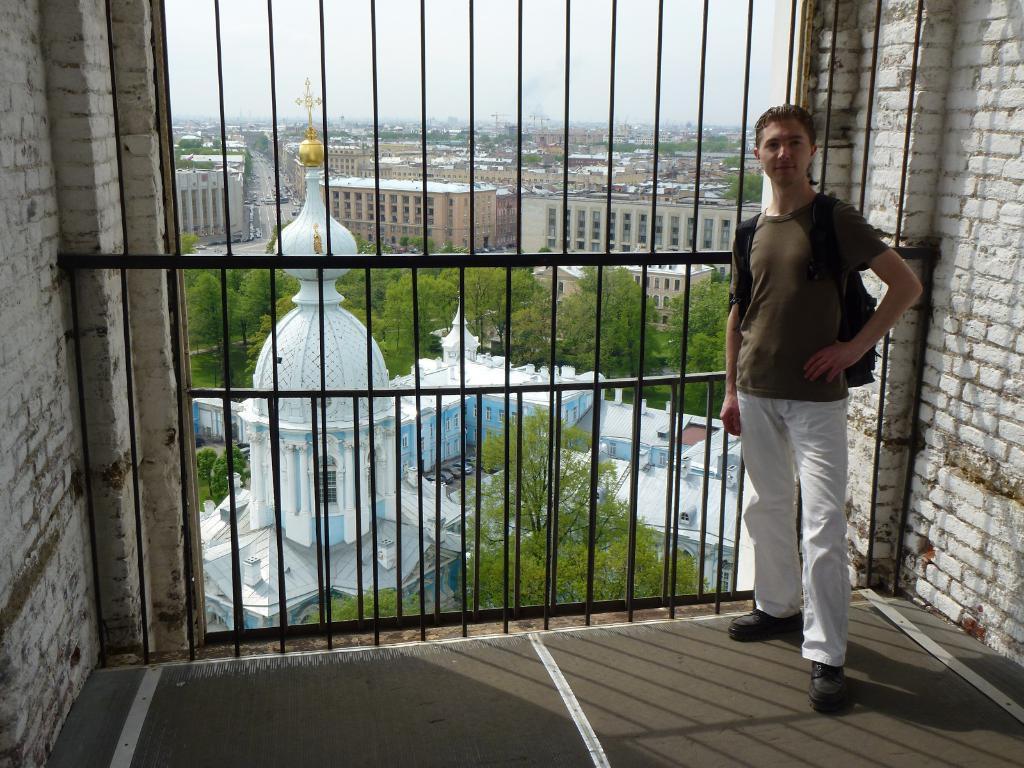In one or two sentences, can you explain what this image depicts? In this picture there is a man standing. At the back there are buildings and trees behind the railing. At the top there is sky. At the bottom there is a floor and there are vehicles. 